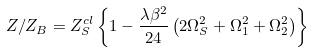<formula> <loc_0><loc_0><loc_500><loc_500>Z / Z _ { B } = Z _ { S } ^ { c l } \left \{ 1 - \frac { \lambda \beta ^ { 2 } } { 2 4 } \left ( 2 \Omega _ { S } ^ { 2 } + \Omega _ { 1 } ^ { 2 } + \Omega _ { 2 } ^ { 2 } \right ) \right \}</formula> 